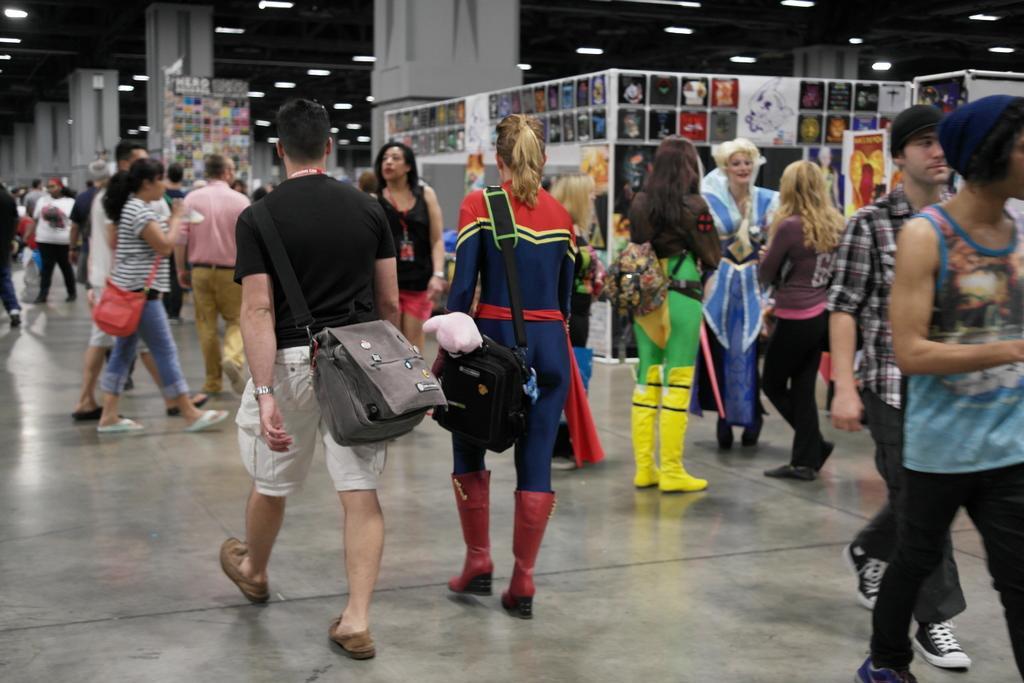Please provide a concise description of this image. This is a picture taken in a hall, there are group of people standing on floor. Background of this people is a pillar and a roof with lights. 